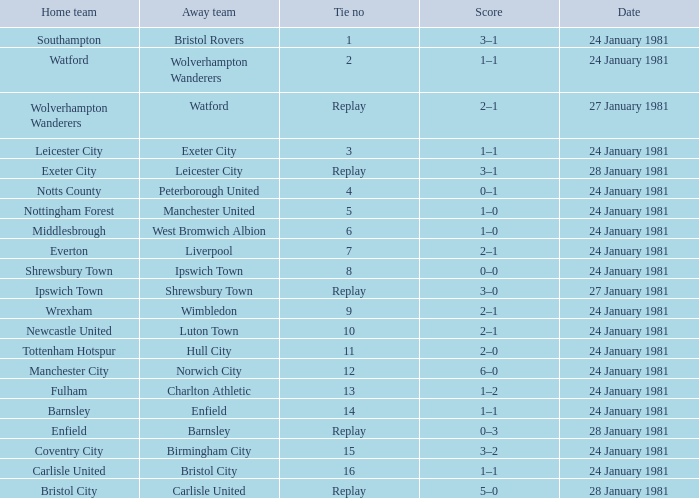What is the score when the tie is 9? 2–1. Could you help me parse every detail presented in this table? {'header': ['Home team', 'Away team', 'Tie no', 'Score', 'Date'], 'rows': [['Southampton', 'Bristol Rovers', '1', '3–1', '24 January 1981'], ['Watford', 'Wolverhampton Wanderers', '2', '1–1', '24 January 1981'], ['Wolverhampton Wanderers', 'Watford', 'Replay', '2–1', '27 January 1981'], ['Leicester City', 'Exeter City', '3', '1–1', '24 January 1981'], ['Exeter City', 'Leicester City', 'Replay', '3–1', '28 January 1981'], ['Notts County', 'Peterborough United', '4', '0–1', '24 January 1981'], ['Nottingham Forest', 'Manchester United', '5', '1–0', '24 January 1981'], ['Middlesbrough', 'West Bromwich Albion', '6', '1–0', '24 January 1981'], ['Everton', 'Liverpool', '7', '2–1', '24 January 1981'], ['Shrewsbury Town', 'Ipswich Town', '8', '0–0', '24 January 1981'], ['Ipswich Town', 'Shrewsbury Town', 'Replay', '3–0', '27 January 1981'], ['Wrexham', 'Wimbledon', '9', '2–1', '24 January 1981'], ['Newcastle United', 'Luton Town', '10', '2–1', '24 January 1981'], ['Tottenham Hotspur', 'Hull City', '11', '2–0', '24 January 1981'], ['Manchester City', 'Norwich City', '12', '6–0', '24 January 1981'], ['Fulham', 'Charlton Athletic', '13', '1–2', '24 January 1981'], ['Barnsley', 'Enfield', '14', '1–1', '24 January 1981'], ['Enfield', 'Barnsley', 'Replay', '0–3', '28 January 1981'], ['Coventry City', 'Birmingham City', '15', '3–2', '24 January 1981'], ['Carlisle United', 'Bristol City', '16', '1–1', '24 January 1981'], ['Bristol City', 'Carlisle United', 'Replay', '5–0', '28 January 1981']]} 